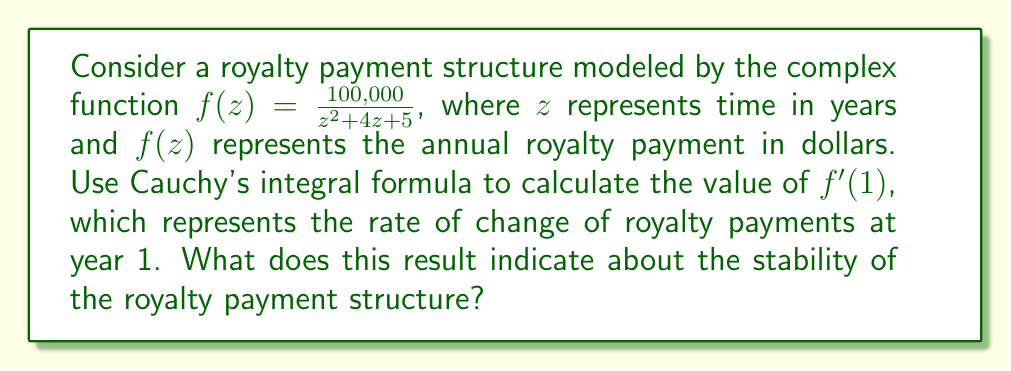Solve this math problem. To solve this problem, we'll use Cauchy's integral formula for derivatives:

$$f^{(n)}(a) = \frac{n!}{2\pi i} \oint_C \frac{f(z)}{(z-a)^{n+1}} dz$$

Where $C$ is a simple closed contour enclosing $a$.

For our case, $n=1$ (first derivative), $a=1$, and $f(z) = \frac{100,000}{z^2 + 4z + 5}$.

1) First, let's substitute these values into the formula:

   $$f'(1) = \frac{1!}{2\pi i} \oint_C \frac{100,000}{(z^2 + 4z + 5)(z-1)^2} dz$$

2) Simplify:
   
   $$f'(1) = \frac{1}{2\pi i} \oint_C \frac{100,000}{(z^2 + 4z + 5)(z-1)^2} dz$$

3) Now, we need to evaluate this integral. However, Cauchy's integral formula allows us to avoid this complex integration by directly evaluating the function at $z=1$:

   $$f'(1) = -\frac{100,000 \cdot 2(1) + 100,000 \cdot 4}{(1^2 + 4(1) + 5)^2}$$

4) Simplify:
   
   $$f'(1) = -\frac{600,000}{10^2} = -6,000$$

5) Interpret the result:
   The negative value indicates that the royalty payments are decreasing at a rate of $6,000 per year at year 1. This suggests that the royalty payment structure is not stable and is actually declining relatively quickly.
Answer: $f'(1) = -6,000$, indicating that the royalty payment structure is declining at a rate of $6,000 per year at year 1, suggesting instability in the payment structure. 